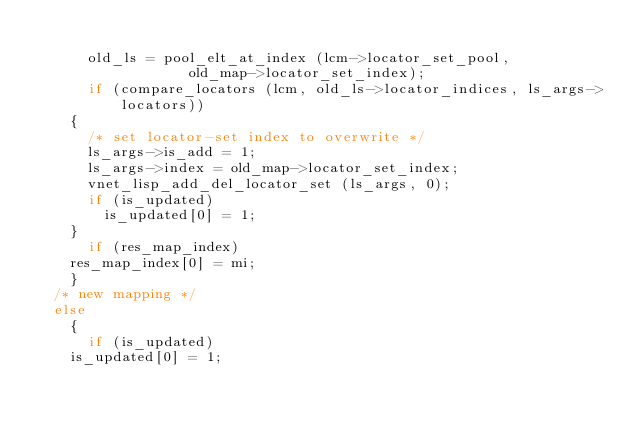Convert code to text. <code><loc_0><loc_0><loc_500><loc_500><_C_>
      old_ls = pool_elt_at_index (lcm->locator_set_pool,
				  old_map->locator_set_index);
      if (compare_locators (lcm, old_ls->locator_indices, ls_args->locators))
	{
	  /* set locator-set index to overwrite */
	  ls_args->is_add = 1;
	  ls_args->index = old_map->locator_set_index;
	  vnet_lisp_add_del_locator_set (ls_args, 0);
	  if (is_updated)
	    is_updated[0] = 1;
	}
      if (res_map_index)
	res_map_index[0] = mi;
    }
  /* new mapping */
  else
    {
      if (is_updated)
	is_updated[0] = 1;</code> 